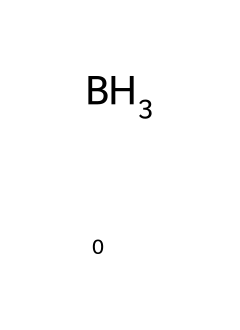What is the chemical formula of the compound? The SMILES representation [BH3] indicates the presence of one boron atom (B) and three hydrogen atoms (H), together forming the chemical formula B-H3.
Answer: B-H3 How many hydrogen atoms are present in this molecule? The SMILES notation shows three hydrogen atoms (H) bonded to one boron atom (B), so there are three hydrogen atoms in total.
Answer: 3 Is this compound polar or nonpolar? Borane (BH3) has a trigonal planar shape due to the electron distribution around the boron atom, making it nonpolar as the bond dipoles cancel out.
Answer: nonpolar Which type of bond is present in this compound? The only bonds in the structure are B-H single covalent bonds, characteristic of the bonding in borane compounds.
Answer: single covalent Can this compound act as a Lewis acid? Borane, with an incomplete octet, can accept an electron pair, which classifies it as a Lewis acid, commonly seen in various chemical reactions.
Answer: yes What role does borane play in traditional dyes? Borane compounds can be utilized as reducing agents in dye synthesis, particularly for vibrant and stable colors in medieval pigments.
Answer: reducing agent What is the coordination number of boron in this structure? In [BH3], the boron atom is bonded to three hydrogen atoms, giving it a coordination number of 3.
Answer: 3 